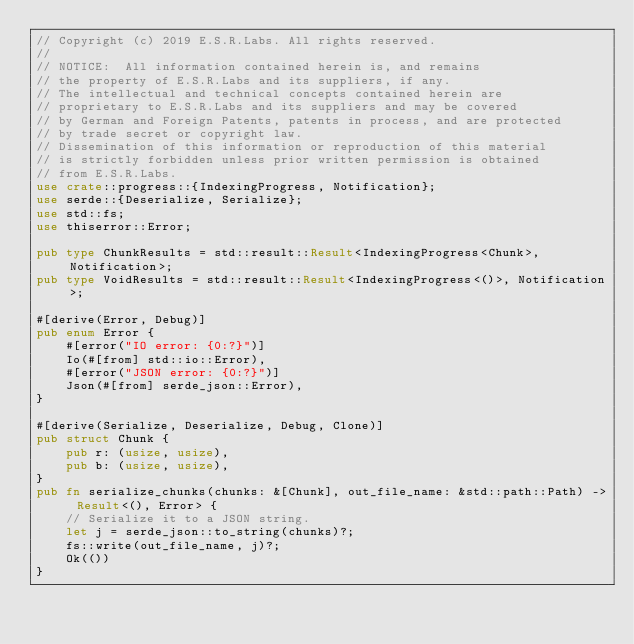<code> <loc_0><loc_0><loc_500><loc_500><_Rust_>// Copyright (c) 2019 E.S.R.Labs. All rights reserved.
//
// NOTICE:  All information contained herein is, and remains
// the property of E.S.R.Labs and its suppliers, if any.
// The intellectual and technical concepts contained herein are
// proprietary to E.S.R.Labs and its suppliers and may be covered
// by German and Foreign Patents, patents in process, and are protected
// by trade secret or copyright law.
// Dissemination of this information or reproduction of this material
// is strictly forbidden unless prior written permission is obtained
// from E.S.R.Labs.
use crate::progress::{IndexingProgress, Notification};
use serde::{Deserialize, Serialize};
use std::fs;
use thiserror::Error;

pub type ChunkResults = std::result::Result<IndexingProgress<Chunk>, Notification>;
pub type VoidResults = std::result::Result<IndexingProgress<()>, Notification>;

#[derive(Error, Debug)]
pub enum Error {
    #[error("IO error: {0:?}")]
    Io(#[from] std::io::Error),
    #[error("JSON error: {0:?}")]
    Json(#[from] serde_json::Error),
}

#[derive(Serialize, Deserialize, Debug, Clone)]
pub struct Chunk {
    pub r: (usize, usize),
    pub b: (usize, usize),
}
pub fn serialize_chunks(chunks: &[Chunk], out_file_name: &std::path::Path) -> Result<(), Error> {
    // Serialize it to a JSON string.
    let j = serde_json::to_string(chunks)?;
    fs::write(out_file_name, j)?;
    Ok(())
}</code> 